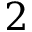Convert formula to latex. <formula><loc_0><loc_0><loc_500><loc_500>2</formula> 